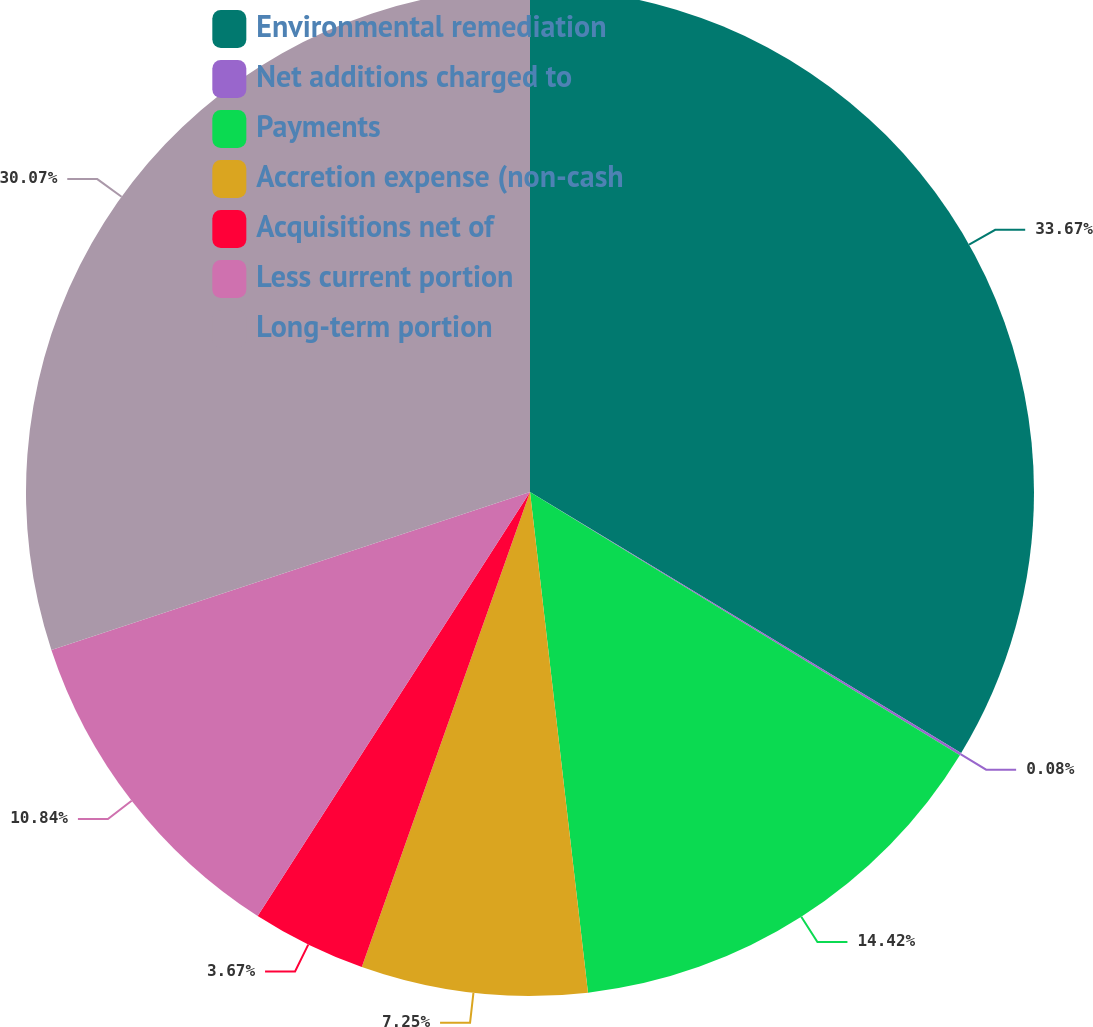<chart> <loc_0><loc_0><loc_500><loc_500><pie_chart><fcel>Environmental remediation<fcel>Net additions charged to<fcel>Payments<fcel>Accretion expense (non-cash<fcel>Acquisitions net of<fcel>Less current portion<fcel>Long-term portion<nl><fcel>33.66%<fcel>0.08%<fcel>14.42%<fcel>7.25%<fcel>3.67%<fcel>10.84%<fcel>30.07%<nl></chart> 